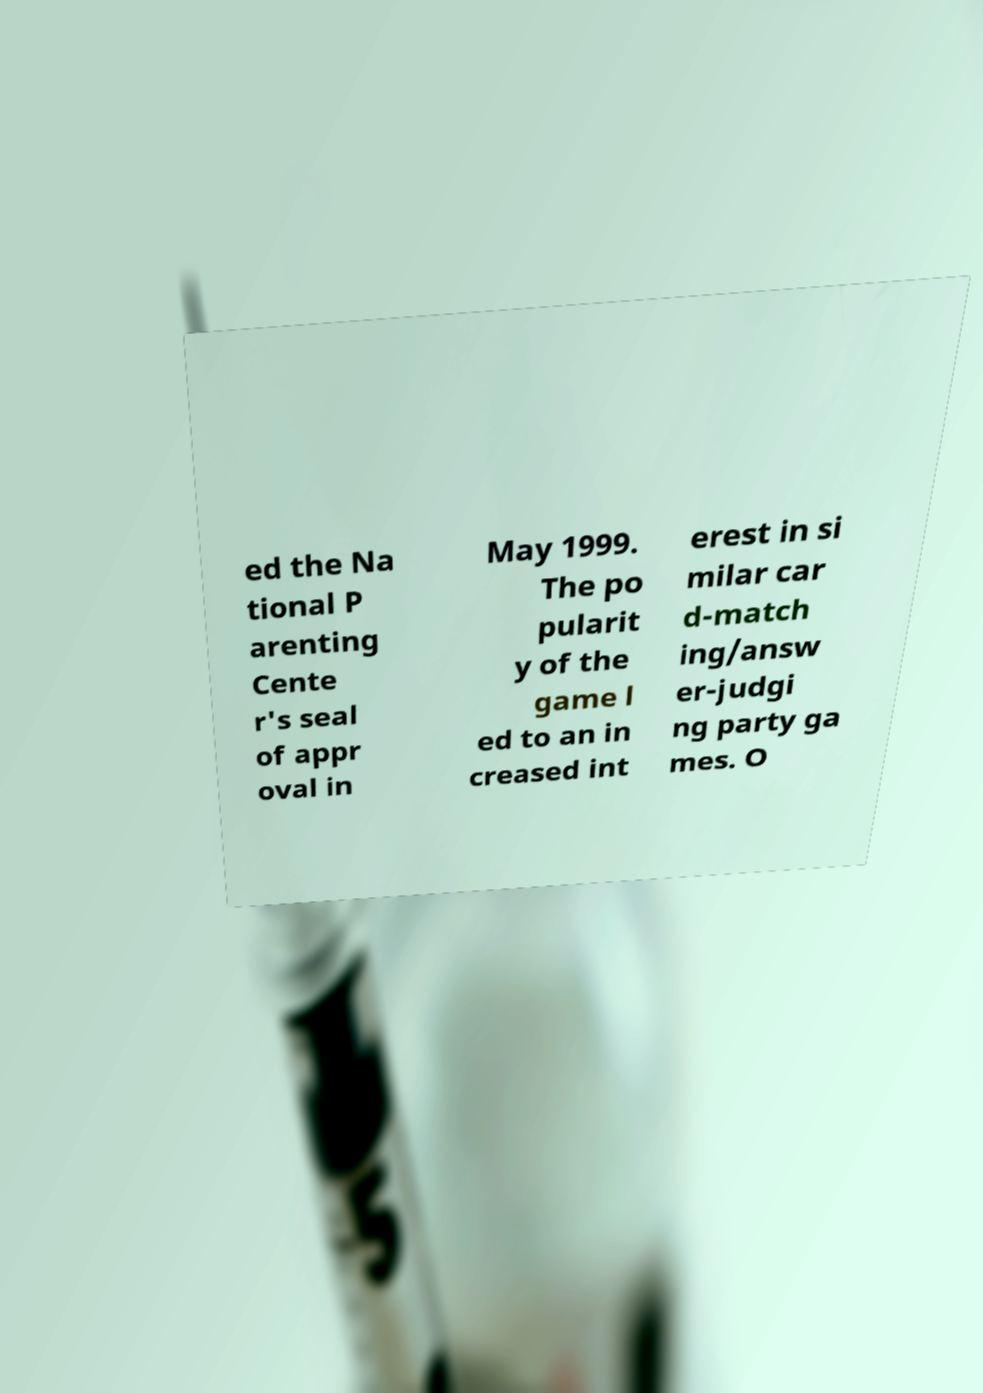Could you extract and type out the text from this image? ed the Na tional P arenting Cente r's seal of appr oval in May 1999. The po pularit y of the game l ed to an in creased int erest in si milar car d-match ing/answ er-judgi ng party ga mes. O 